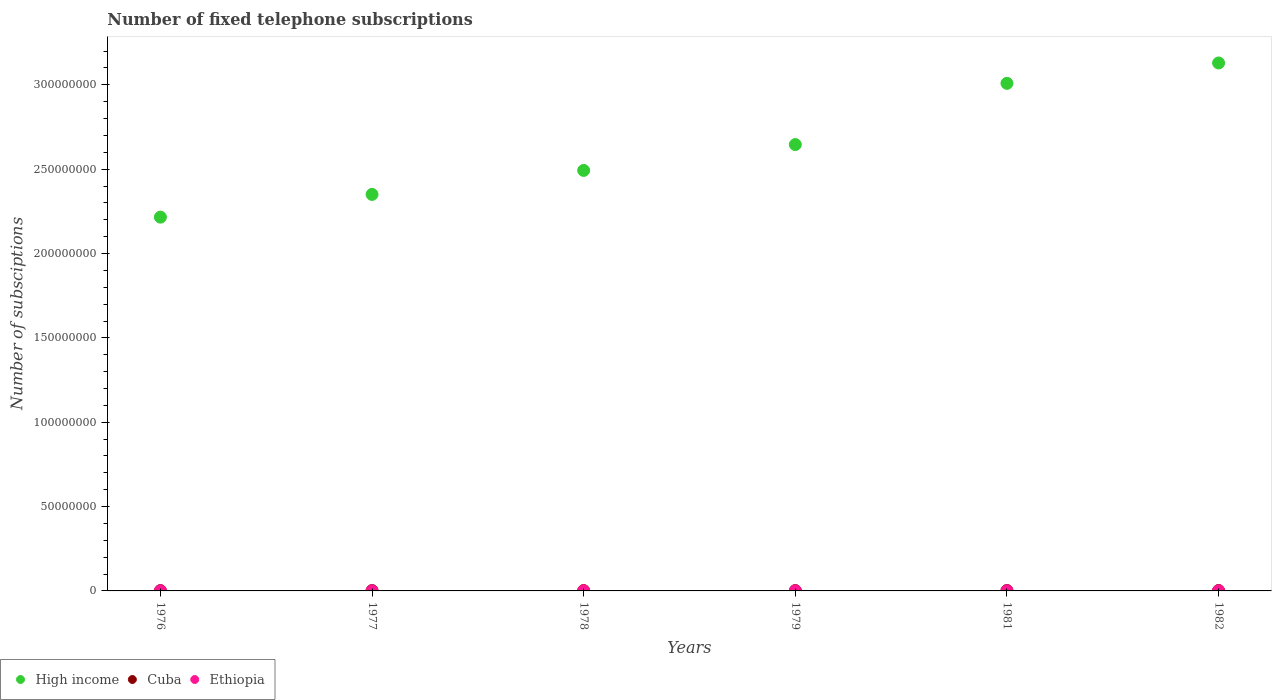What is the number of fixed telephone subscriptions in High income in 1979?
Offer a very short reply. 2.65e+08. Across all years, what is the maximum number of fixed telephone subscriptions in Cuba?
Your response must be concise. 2.44e+05. Across all years, what is the minimum number of fixed telephone subscriptions in High income?
Give a very brief answer. 2.22e+08. In which year was the number of fixed telephone subscriptions in Cuba minimum?
Ensure brevity in your answer.  1978. What is the total number of fixed telephone subscriptions in Ethiopia in the graph?
Make the answer very short. 3.73e+05. What is the difference between the number of fixed telephone subscriptions in Cuba in 1979 and that in 1981?
Your answer should be very brief. -2.11e+04. What is the difference between the number of fixed telephone subscriptions in Cuba in 1979 and the number of fixed telephone subscriptions in Ethiopia in 1977?
Your answer should be very brief. 1.54e+05. What is the average number of fixed telephone subscriptions in Cuba per year?
Ensure brevity in your answer.  2.13e+05. In the year 1976, what is the difference between the number of fixed telephone subscriptions in Ethiopia and number of fixed telephone subscriptions in Cuba?
Offer a very short reply. -1.45e+05. What is the ratio of the number of fixed telephone subscriptions in Ethiopia in 1978 to that in 1981?
Make the answer very short. 0.86. What is the difference between the highest and the second highest number of fixed telephone subscriptions in High income?
Offer a very short reply. 1.21e+07. What is the difference between the highest and the lowest number of fixed telephone subscriptions in Cuba?
Offer a terse response. 4.80e+04. In how many years, is the number of fixed telephone subscriptions in High income greater than the average number of fixed telephone subscriptions in High income taken over all years?
Your answer should be compact. 3. Is the sum of the number of fixed telephone subscriptions in Cuba in 1979 and 1981 greater than the maximum number of fixed telephone subscriptions in High income across all years?
Provide a succinct answer. No. Does the number of fixed telephone subscriptions in Cuba monotonically increase over the years?
Give a very brief answer. No. Is the number of fixed telephone subscriptions in Ethiopia strictly less than the number of fixed telephone subscriptions in Cuba over the years?
Ensure brevity in your answer.  Yes. How many dotlines are there?
Offer a very short reply. 3. What is the difference between two consecutive major ticks on the Y-axis?
Offer a very short reply. 5.00e+07. Does the graph contain any zero values?
Offer a very short reply. No. Does the graph contain grids?
Provide a short and direct response. No. What is the title of the graph?
Your response must be concise. Number of fixed telephone subscriptions. Does "Ghana" appear as one of the legend labels in the graph?
Provide a succinct answer. No. What is the label or title of the X-axis?
Keep it short and to the point. Years. What is the label or title of the Y-axis?
Offer a very short reply. Number of subsciptions. What is the Number of subsciptions in High income in 1976?
Your response must be concise. 2.22e+08. What is the Number of subsciptions of Cuba in 1976?
Your answer should be very brief. 1.97e+05. What is the Number of subsciptions of Ethiopia in 1976?
Give a very brief answer. 5.21e+04. What is the Number of subsciptions of High income in 1977?
Your response must be concise. 2.35e+08. What is the Number of subsciptions of Cuba in 1977?
Offer a very short reply. 1.97e+05. What is the Number of subsciptions in Ethiopia in 1977?
Keep it short and to the point. 5.72e+04. What is the Number of subsciptions in High income in 1978?
Your answer should be very brief. 2.49e+08. What is the Number of subsciptions in Cuba in 1978?
Your answer should be very brief. 1.96e+05. What is the Number of subsciptions of Ethiopia in 1978?
Provide a succinct answer. 5.93e+04. What is the Number of subsciptions in High income in 1979?
Make the answer very short. 2.65e+08. What is the Number of subsciptions of Cuba in 1979?
Make the answer very short. 2.11e+05. What is the Number of subsciptions of Ethiopia in 1979?
Offer a terse response. 6.12e+04. What is the Number of subsciptions in High income in 1981?
Offer a terse response. 3.01e+08. What is the Number of subsciptions of Cuba in 1981?
Offer a terse response. 2.32e+05. What is the Number of subsciptions of Ethiopia in 1981?
Provide a short and direct response. 6.88e+04. What is the Number of subsciptions in High income in 1982?
Provide a succinct answer. 3.13e+08. What is the Number of subsciptions in Cuba in 1982?
Ensure brevity in your answer.  2.44e+05. What is the Number of subsciptions of Ethiopia in 1982?
Ensure brevity in your answer.  7.46e+04. Across all years, what is the maximum Number of subsciptions of High income?
Keep it short and to the point. 3.13e+08. Across all years, what is the maximum Number of subsciptions in Cuba?
Give a very brief answer. 2.44e+05. Across all years, what is the maximum Number of subsciptions in Ethiopia?
Give a very brief answer. 7.46e+04. Across all years, what is the minimum Number of subsciptions of High income?
Ensure brevity in your answer.  2.22e+08. Across all years, what is the minimum Number of subsciptions of Cuba?
Offer a terse response. 1.96e+05. Across all years, what is the minimum Number of subsciptions of Ethiopia?
Keep it short and to the point. 5.21e+04. What is the total Number of subsciptions in High income in the graph?
Keep it short and to the point. 1.58e+09. What is the total Number of subsciptions of Cuba in the graph?
Offer a terse response. 1.28e+06. What is the total Number of subsciptions of Ethiopia in the graph?
Offer a very short reply. 3.73e+05. What is the difference between the Number of subsciptions in High income in 1976 and that in 1977?
Provide a succinct answer. -1.35e+07. What is the difference between the Number of subsciptions of Cuba in 1976 and that in 1977?
Your answer should be compact. 0. What is the difference between the Number of subsciptions in Ethiopia in 1976 and that in 1977?
Your answer should be very brief. -5090. What is the difference between the Number of subsciptions of High income in 1976 and that in 1978?
Keep it short and to the point. -2.77e+07. What is the difference between the Number of subsciptions in Cuba in 1976 and that in 1978?
Your answer should be very brief. 1000. What is the difference between the Number of subsciptions in Ethiopia in 1976 and that in 1978?
Provide a succinct answer. -7226. What is the difference between the Number of subsciptions of High income in 1976 and that in 1979?
Your answer should be compact. -4.30e+07. What is the difference between the Number of subsciptions of Cuba in 1976 and that in 1979?
Offer a terse response. -1.40e+04. What is the difference between the Number of subsciptions of Ethiopia in 1976 and that in 1979?
Offer a very short reply. -9065. What is the difference between the Number of subsciptions of High income in 1976 and that in 1981?
Your answer should be compact. -7.93e+07. What is the difference between the Number of subsciptions of Cuba in 1976 and that in 1981?
Offer a terse response. -3.51e+04. What is the difference between the Number of subsciptions in Ethiopia in 1976 and that in 1981?
Make the answer very short. -1.67e+04. What is the difference between the Number of subsciptions of High income in 1976 and that in 1982?
Your response must be concise. -9.14e+07. What is the difference between the Number of subsciptions of Cuba in 1976 and that in 1982?
Offer a very short reply. -4.70e+04. What is the difference between the Number of subsciptions of Ethiopia in 1976 and that in 1982?
Keep it short and to the point. -2.25e+04. What is the difference between the Number of subsciptions in High income in 1977 and that in 1978?
Give a very brief answer. -1.42e+07. What is the difference between the Number of subsciptions in Cuba in 1977 and that in 1978?
Provide a succinct answer. 1000. What is the difference between the Number of subsciptions of Ethiopia in 1977 and that in 1978?
Provide a short and direct response. -2136. What is the difference between the Number of subsciptions in High income in 1977 and that in 1979?
Give a very brief answer. -2.95e+07. What is the difference between the Number of subsciptions of Cuba in 1977 and that in 1979?
Provide a succinct answer. -1.40e+04. What is the difference between the Number of subsciptions in Ethiopia in 1977 and that in 1979?
Your response must be concise. -3975. What is the difference between the Number of subsciptions of High income in 1977 and that in 1981?
Provide a short and direct response. -6.58e+07. What is the difference between the Number of subsciptions in Cuba in 1977 and that in 1981?
Give a very brief answer. -3.51e+04. What is the difference between the Number of subsciptions in Ethiopia in 1977 and that in 1981?
Make the answer very short. -1.16e+04. What is the difference between the Number of subsciptions in High income in 1977 and that in 1982?
Provide a succinct answer. -7.79e+07. What is the difference between the Number of subsciptions in Cuba in 1977 and that in 1982?
Provide a succinct answer. -4.70e+04. What is the difference between the Number of subsciptions of Ethiopia in 1977 and that in 1982?
Offer a terse response. -1.74e+04. What is the difference between the Number of subsciptions in High income in 1978 and that in 1979?
Offer a terse response. -1.53e+07. What is the difference between the Number of subsciptions in Cuba in 1978 and that in 1979?
Keep it short and to the point. -1.50e+04. What is the difference between the Number of subsciptions of Ethiopia in 1978 and that in 1979?
Ensure brevity in your answer.  -1839. What is the difference between the Number of subsciptions in High income in 1978 and that in 1981?
Provide a succinct answer. -5.16e+07. What is the difference between the Number of subsciptions in Cuba in 1978 and that in 1981?
Ensure brevity in your answer.  -3.61e+04. What is the difference between the Number of subsciptions in Ethiopia in 1978 and that in 1981?
Ensure brevity in your answer.  -9466. What is the difference between the Number of subsciptions of High income in 1978 and that in 1982?
Make the answer very short. -6.37e+07. What is the difference between the Number of subsciptions in Cuba in 1978 and that in 1982?
Give a very brief answer. -4.80e+04. What is the difference between the Number of subsciptions of Ethiopia in 1978 and that in 1982?
Keep it short and to the point. -1.52e+04. What is the difference between the Number of subsciptions in High income in 1979 and that in 1981?
Offer a terse response. -3.63e+07. What is the difference between the Number of subsciptions in Cuba in 1979 and that in 1981?
Offer a terse response. -2.11e+04. What is the difference between the Number of subsciptions of Ethiopia in 1979 and that in 1981?
Give a very brief answer. -7627. What is the difference between the Number of subsciptions in High income in 1979 and that in 1982?
Your answer should be compact. -4.84e+07. What is the difference between the Number of subsciptions of Cuba in 1979 and that in 1982?
Ensure brevity in your answer.  -3.30e+04. What is the difference between the Number of subsciptions in Ethiopia in 1979 and that in 1982?
Your answer should be very brief. -1.34e+04. What is the difference between the Number of subsciptions of High income in 1981 and that in 1982?
Your answer should be very brief. -1.21e+07. What is the difference between the Number of subsciptions of Cuba in 1981 and that in 1982?
Your answer should be compact. -1.19e+04. What is the difference between the Number of subsciptions of Ethiopia in 1981 and that in 1982?
Make the answer very short. -5770. What is the difference between the Number of subsciptions in High income in 1976 and the Number of subsciptions in Cuba in 1977?
Keep it short and to the point. 2.21e+08. What is the difference between the Number of subsciptions of High income in 1976 and the Number of subsciptions of Ethiopia in 1977?
Your answer should be compact. 2.22e+08. What is the difference between the Number of subsciptions of Cuba in 1976 and the Number of subsciptions of Ethiopia in 1977?
Your answer should be compact. 1.40e+05. What is the difference between the Number of subsciptions of High income in 1976 and the Number of subsciptions of Cuba in 1978?
Keep it short and to the point. 2.21e+08. What is the difference between the Number of subsciptions of High income in 1976 and the Number of subsciptions of Ethiopia in 1978?
Your answer should be compact. 2.22e+08. What is the difference between the Number of subsciptions of Cuba in 1976 and the Number of subsciptions of Ethiopia in 1978?
Give a very brief answer. 1.38e+05. What is the difference between the Number of subsciptions of High income in 1976 and the Number of subsciptions of Cuba in 1979?
Keep it short and to the point. 2.21e+08. What is the difference between the Number of subsciptions of High income in 1976 and the Number of subsciptions of Ethiopia in 1979?
Give a very brief answer. 2.22e+08. What is the difference between the Number of subsciptions in Cuba in 1976 and the Number of subsciptions in Ethiopia in 1979?
Your answer should be very brief. 1.36e+05. What is the difference between the Number of subsciptions in High income in 1976 and the Number of subsciptions in Cuba in 1981?
Keep it short and to the point. 2.21e+08. What is the difference between the Number of subsciptions in High income in 1976 and the Number of subsciptions in Ethiopia in 1981?
Your answer should be compact. 2.22e+08. What is the difference between the Number of subsciptions of Cuba in 1976 and the Number of subsciptions of Ethiopia in 1981?
Keep it short and to the point. 1.28e+05. What is the difference between the Number of subsciptions in High income in 1976 and the Number of subsciptions in Cuba in 1982?
Offer a terse response. 2.21e+08. What is the difference between the Number of subsciptions of High income in 1976 and the Number of subsciptions of Ethiopia in 1982?
Provide a short and direct response. 2.22e+08. What is the difference between the Number of subsciptions in Cuba in 1976 and the Number of subsciptions in Ethiopia in 1982?
Your response must be concise. 1.22e+05. What is the difference between the Number of subsciptions of High income in 1977 and the Number of subsciptions of Cuba in 1978?
Give a very brief answer. 2.35e+08. What is the difference between the Number of subsciptions of High income in 1977 and the Number of subsciptions of Ethiopia in 1978?
Offer a terse response. 2.35e+08. What is the difference between the Number of subsciptions in Cuba in 1977 and the Number of subsciptions in Ethiopia in 1978?
Provide a short and direct response. 1.38e+05. What is the difference between the Number of subsciptions in High income in 1977 and the Number of subsciptions in Cuba in 1979?
Your response must be concise. 2.35e+08. What is the difference between the Number of subsciptions in High income in 1977 and the Number of subsciptions in Ethiopia in 1979?
Provide a succinct answer. 2.35e+08. What is the difference between the Number of subsciptions in Cuba in 1977 and the Number of subsciptions in Ethiopia in 1979?
Provide a succinct answer. 1.36e+05. What is the difference between the Number of subsciptions in High income in 1977 and the Number of subsciptions in Cuba in 1981?
Your answer should be very brief. 2.35e+08. What is the difference between the Number of subsciptions in High income in 1977 and the Number of subsciptions in Ethiopia in 1981?
Your response must be concise. 2.35e+08. What is the difference between the Number of subsciptions in Cuba in 1977 and the Number of subsciptions in Ethiopia in 1981?
Your answer should be very brief. 1.28e+05. What is the difference between the Number of subsciptions in High income in 1977 and the Number of subsciptions in Cuba in 1982?
Provide a short and direct response. 2.35e+08. What is the difference between the Number of subsciptions in High income in 1977 and the Number of subsciptions in Ethiopia in 1982?
Offer a terse response. 2.35e+08. What is the difference between the Number of subsciptions of Cuba in 1977 and the Number of subsciptions of Ethiopia in 1982?
Ensure brevity in your answer.  1.22e+05. What is the difference between the Number of subsciptions in High income in 1978 and the Number of subsciptions in Cuba in 1979?
Offer a very short reply. 2.49e+08. What is the difference between the Number of subsciptions of High income in 1978 and the Number of subsciptions of Ethiopia in 1979?
Give a very brief answer. 2.49e+08. What is the difference between the Number of subsciptions of Cuba in 1978 and the Number of subsciptions of Ethiopia in 1979?
Ensure brevity in your answer.  1.35e+05. What is the difference between the Number of subsciptions in High income in 1978 and the Number of subsciptions in Cuba in 1981?
Your answer should be compact. 2.49e+08. What is the difference between the Number of subsciptions of High income in 1978 and the Number of subsciptions of Ethiopia in 1981?
Your response must be concise. 2.49e+08. What is the difference between the Number of subsciptions in Cuba in 1978 and the Number of subsciptions in Ethiopia in 1981?
Provide a short and direct response. 1.27e+05. What is the difference between the Number of subsciptions in High income in 1978 and the Number of subsciptions in Cuba in 1982?
Your response must be concise. 2.49e+08. What is the difference between the Number of subsciptions in High income in 1978 and the Number of subsciptions in Ethiopia in 1982?
Make the answer very short. 2.49e+08. What is the difference between the Number of subsciptions of Cuba in 1978 and the Number of subsciptions of Ethiopia in 1982?
Provide a succinct answer. 1.21e+05. What is the difference between the Number of subsciptions of High income in 1979 and the Number of subsciptions of Cuba in 1981?
Make the answer very short. 2.64e+08. What is the difference between the Number of subsciptions in High income in 1979 and the Number of subsciptions in Ethiopia in 1981?
Your response must be concise. 2.65e+08. What is the difference between the Number of subsciptions of Cuba in 1979 and the Number of subsciptions of Ethiopia in 1981?
Ensure brevity in your answer.  1.42e+05. What is the difference between the Number of subsciptions in High income in 1979 and the Number of subsciptions in Cuba in 1982?
Your answer should be compact. 2.64e+08. What is the difference between the Number of subsciptions of High income in 1979 and the Number of subsciptions of Ethiopia in 1982?
Your answer should be compact. 2.65e+08. What is the difference between the Number of subsciptions of Cuba in 1979 and the Number of subsciptions of Ethiopia in 1982?
Make the answer very short. 1.36e+05. What is the difference between the Number of subsciptions of High income in 1981 and the Number of subsciptions of Cuba in 1982?
Provide a short and direct response. 3.01e+08. What is the difference between the Number of subsciptions of High income in 1981 and the Number of subsciptions of Ethiopia in 1982?
Your answer should be very brief. 3.01e+08. What is the difference between the Number of subsciptions of Cuba in 1981 and the Number of subsciptions of Ethiopia in 1982?
Ensure brevity in your answer.  1.58e+05. What is the average Number of subsciptions in High income per year?
Ensure brevity in your answer.  2.64e+08. What is the average Number of subsciptions in Cuba per year?
Your response must be concise. 2.13e+05. What is the average Number of subsciptions in Ethiopia per year?
Ensure brevity in your answer.  6.22e+04. In the year 1976, what is the difference between the Number of subsciptions of High income and Number of subsciptions of Cuba?
Your answer should be very brief. 2.21e+08. In the year 1976, what is the difference between the Number of subsciptions of High income and Number of subsciptions of Ethiopia?
Provide a short and direct response. 2.22e+08. In the year 1976, what is the difference between the Number of subsciptions in Cuba and Number of subsciptions in Ethiopia?
Offer a very short reply. 1.45e+05. In the year 1977, what is the difference between the Number of subsciptions in High income and Number of subsciptions in Cuba?
Offer a terse response. 2.35e+08. In the year 1977, what is the difference between the Number of subsciptions in High income and Number of subsciptions in Ethiopia?
Offer a very short reply. 2.35e+08. In the year 1977, what is the difference between the Number of subsciptions of Cuba and Number of subsciptions of Ethiopia?
Provide a short and direct response. 1.40e+05. In the year 1978, what is the difference between the Number of subsciptions in High income and Number of subsciptions in Cuba?
Provide a succinct answer. 2.49e+08. In the year 1978, what is the difference between the Number of subsciptions in High income and Number of subsciptions in Ethiopia?
Ensure brevity in your answer.  2.49e+08. In the year 1978, what is the difference between the Number of subsciptions of Cuba and Number of subsciptions of Ethiopia?
Provide a short and direct response. 1.37e+05. In the year 1979, what is the difference between the Number of subsciptions in High income and Number of subsciptions in Cuba?
Provide a short and direct response. 2.64e+08. In the year 1979, what is the difference between the Number of subsciptions of High income and Number of subsciptions of Ethiopia?
Your answer should be very brief. 2.65e+08. In the year 1979, what is the difference between the Number of subsciptions of Cuba and Number of subsciptions of Ethiopia?
Offer a very short reply. 1.50e+05. In the year 1981, what is the difference between the Number of subsciptions in High income and Number of subsciptions in Cuba?
Keep it short and to the point. 3.01e+08. In the year 1981, what is the difference between the Number of subsciptions of High income and Number of subsciptions of Ethiopia?
Ensure brevity in your answer.  3.01e+08. In the year 1981, what is the difference between the Number of subsciptions of Cuba and Number of subsciptions of Ethiopia?
Give a very brief answer. 1.63e+05. In the year 1982, what is the difference between the Number of subsciptions in High income and Number of subsciptions in Cuba?
Give a very brief answer. 3.13e+08. In the year 1982, what is the difference between the Number of subsciptions in High income and Number of subsciptions in Ethiopia?
Your response must be concise. 3.13e+08. In the year 1982, what is the difference between the Number of subsciptions of Cuba and Number of subsciptions of Ethiopia?
Give a very brief answer. 1.69e+05. What is the ratio of the Number of subsciptions of High income in 1976 to that in 1977?
Offer a terse response. 0.94. What is the ratio of the Number of subsciptions of Ethiopia in 1976 to that in 1977?
Provide a short and direct response. 0.91. What is the ratio of the Number of subsciptions of High income in 1976 to that in 1978?
Give a very brief answer. 0.89. What is the ratio of the Number of subsciptions in Cuba in 1976 to that in 1978?
Give a very brief answer. 1.01. What is the ratio of the Number of subsciptions of Ethiopia in 1976 to that in 1978?
Your response must be concise. 0.88. What is the ratio of the Number of subsciptions of High income in 1976 to that in 1979?
Keep it short and to the point. 0.84. What is the ratio of the Number of subsciptions in Cuba in 1976 to that in 1979?
Provide a short and direct response. 0.93. What is the ratio of the Number of subsciptions of Ethiopia in 1976 to that in 1979?
Your answer should be compact. 0.85. What is the ratio of the Number of subsciptions of High income in 1976 to that in 1981?
Ensure brevity in your answer.  0.74. What is the ratio of the Number of subsciptions in Cuba in 1976 to that in 1981?
Your answer should be compact. 0.85. What is the ratio of the Number of subsciptions of Ethiopia in 1976 to that in 1981?
Provide a short and direct response. 0.76. What is the ratio of the Number of subsciptions in High income in 1976 to that in 1982?
Ensure brevity in your answer.  0.71. What is the ratio of the Number of subsciptions in Cuba in 1976 to that in 1982?
Make the answer very short. 0.81. What is the ratio of the Number of subsciptions of Ethiopia in 1976 to that in 1982?
Provide a short and direct response. 0.7. What is the ratio of the Number of subsciptions of High income in 1977 to that in 1978?
Keep it short and to the point. 0.94. What is the ratio of the Number of subsciptions of Ethiopia in 1977 to that in 1978?
Provide a succinct answer. 0.96. What is the ratio of the Number of subsciptions of High income in 1977 to that in 1979?
Offer a terse response. 0.89. What is the ratio of the Number of subsciptions of Cuba in 1977 to that in 1979?
Your answer should be very brief. 0.93. What is the ratio of the Number of subsciptions of Ethiopia in 1977 to that in 1979?
Your answer should be compact. 0.94. What is the ratio of the Number of subsciptions in High income in 1977 to that in 1981?
Offer a very short reply. 0.78. What is the ratio of the Number of subsciptions of Cuba in 1977 to that in 1981?
Offer a terse response. 0.85. What is the ratio of the Number of subsciptions of Ethiopia in 1977 to that in 1981?
Offer a terse response. 0.83. What is the ratio of the Number of subsciptions in High income in 1977 to that in 1982?
Offer a very short reply. 0.75. What is the ratio of the Number of subsciptions of Cuba in 1977 to that in 1982?
Offer a terse response. 0.81. What is the ratio of the Number of subsciptions in Ethiopia in 1977 to that in 1982?
Make the answer very short. 0.77. What is the ratio of the Number of subsciptions of High income in 1978 to that in 1979?
Give a very brief answer. 0.94. What is the ratio of the Number of subsciptions of Cuba in 1978 to that in 1979?
Provide a succinct answer. 0.93. What is the ratio of the Number of subsciptions in Ethiopia in 1978 to that in 1979?
Give a very brief answer. 0.97. What is the ratio of the Number of subsciptions in High income in 1978 to that in 1981?
Provide a short and direct response. 0.83. What is the ratio of the Number of subsciptions in Cuba in 1978 to that in 1981?
Your response must be concise. 0.84. What is the ratio of the Number of subsciptions in Ethiopia in 1978 to that in 1981?
Make the answer very short. 0.86. What is the ratio of the Number of subsciptions of High income in 1978 to that in 1982?
Ensure brevity in your answer.  0.8. What is the ratio of the Number of subsciptions of Cuba in 1978 to that in 1982?
Offer a very short reply. 0.8. What is the ratio of the Number of subsciptions in Ethiopia in 1978 to that in 1982?
Make the answer very short. 0.8. What is the ratio of the Number of subsciptions of High income in 1979 to that in 1981?
Give a very brief answer. 0.88. What is the ratio of the Number of subsciptions of Ethiopia in 1979 to that in 1981?
Ensure brevity in your answer.  0.89. What is the ratio of the Number of subsciptions of High income in 1979 to that in 1982?
Give a very brief answer. 0.85. What is the ratio of the Number of subsciptions of Cuba in 1979 to that in 1982?
Offer a very short reply. 0.86. What is the ratio of the Number of subsciptions of Ethiopia in 1979 to that in 1982?
Give a very brief answer. 0.82. What is the ratio of the Number of subsciptions of High income in 1981 to that in 1982?
Your answer should be very brief. 0.96. What is the ratio of the Number of subsciptions of Cuba in 1981 to that in 1982?
Your response must be concise. 0.95. What is the ratio of the Number of subsciptions of Ethiopia in 1981 to that in 1982?
Offer a terse response. 0.92. What is the difference between the highest and the second highest Number of subsciptions in High income?
Your answer should be very brief. 1.21e+07. What is the difference between the highest and the second highest Number of subsciptions in Cuba?
Offer a very short reply. 1.19e+04. What is the difference between the highest and the second highest Number of subsciptions of Ethiopia?
Your answer should be very brief. 5770. What is the difference between the highest and the lowest Number of subsciptions of High income?
Make the answer very short. 9.14e+07. What is the difference between the highest and the lowest Number of subsciptions of Cuba?
Keep it short and to the point. 4.80e+04. What is the difference between the highest and the lowest Number of subsciptions of Ethiopia?
Ensure brevity in your answer.  2.25e+04. 